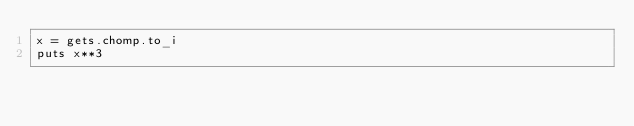Convert code to text. <code><loc_0><loc_0><loc_500><loc_500><_Ruby_>x = gets.chomp.to_i
puts x**3
</code> 